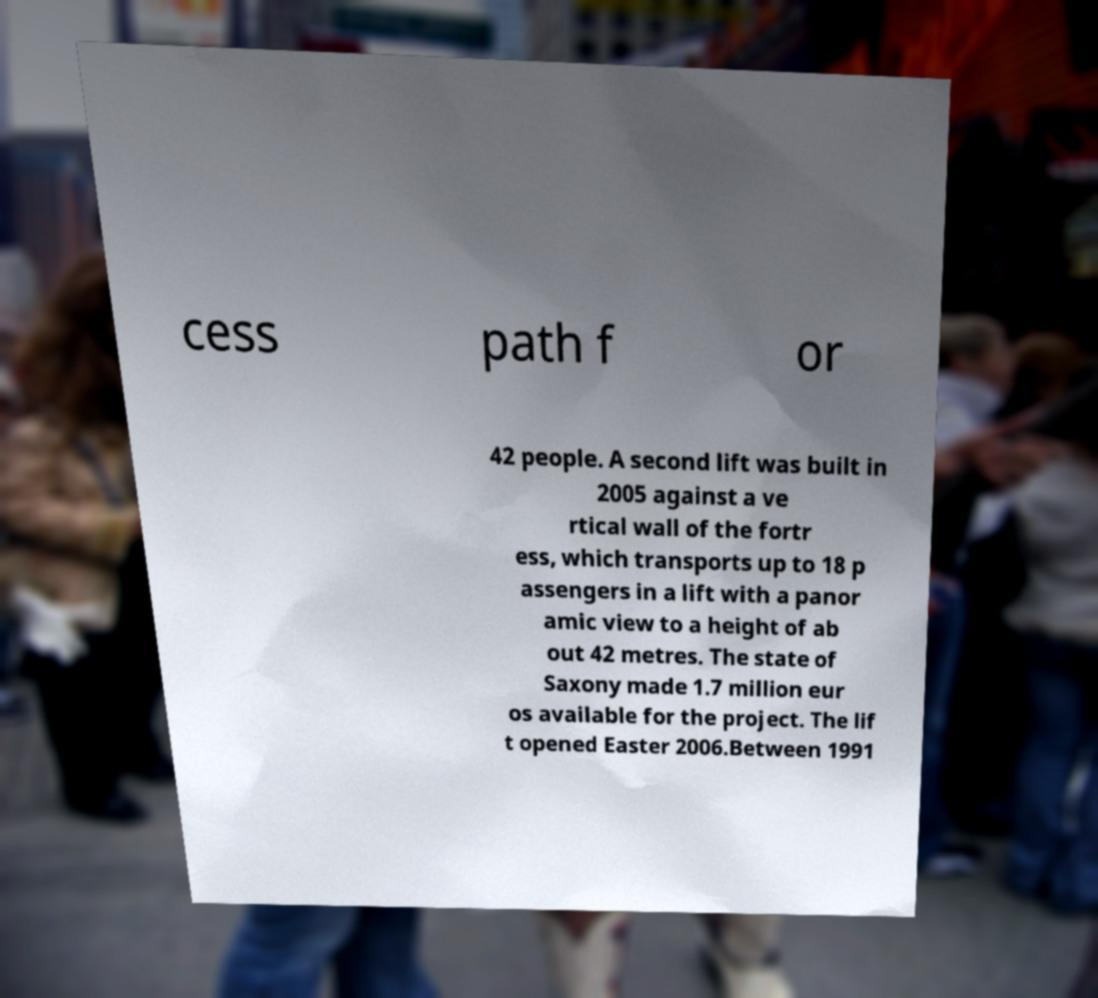Please read and relay the text visible in this image. What does it say? cess path f or 42 people. A second lift was built in 2005 against a ve rtical wall of the fortr ess, which transports up to 18 p assengers in a lift with a panor amic view to a height of ab out 42 metres. The state of Saxony made 1.7 million eur os available for the project. The lif t opened Easter 2006.Between 1991 